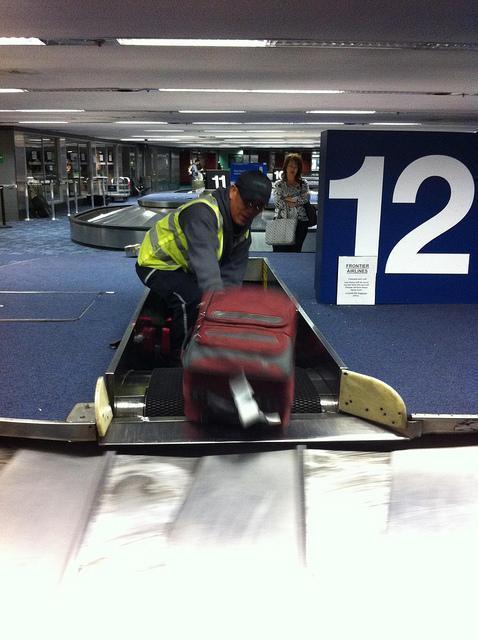Who employs the man in the yellow vest?
Pick the correct solution from the four options below to address the question.
Options: Traffic control, no one, airport, city. Airport. 